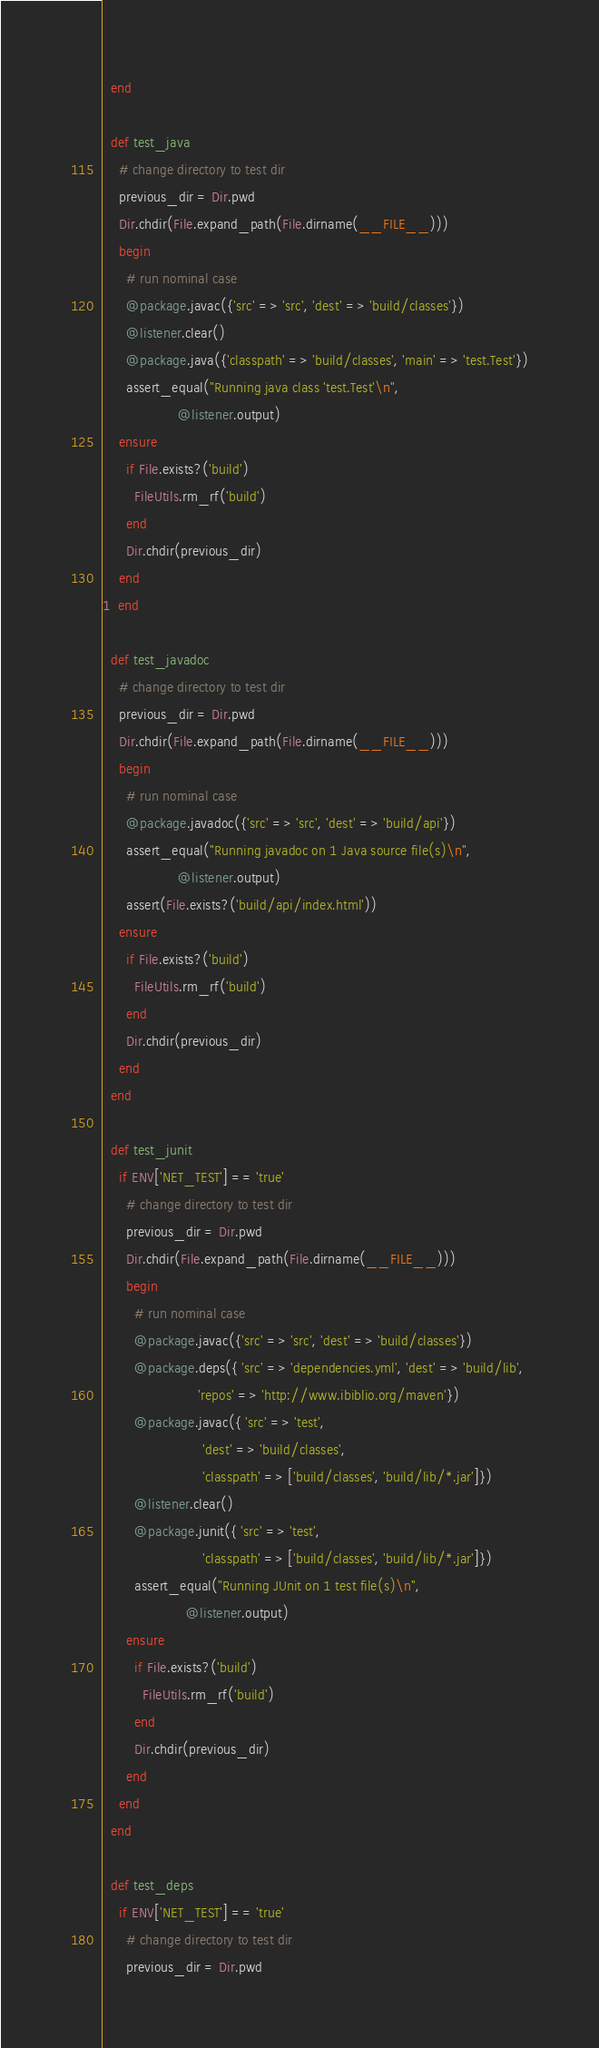Convert code to text. <code><loc_0><loc_0><loc_500><loc_500><_Ruby_>  end

  def test_java
    # change directory to test dir
    previous_dir = Dir.pwd
    Dir.chdir(File.expand_path(File.dirname(__FILE__)))
    begin
      # run nominal case
      @package.javac({'src' => 'src', 'dest' => 'build/classes'})
      @listener.clear()
      @package.java({'classpath' => 'build/classes', 'main' => 'test.Test'})
      assert_equal("Running java class 'test.Test'\n",
                   @listener.output)
    ensure
      if File.exists?('build')
        FileUtils.rm_rf('build')
      end
      Dir.chdir(previous_dir)
    end
1  end

  def test_javadoc
    # change directory to test dir
    previous_dir = Dir.pwd
    Dir.chdir(File.expand_path(File.dirname(__FILE__)))
    begin
      # run nominal case
      @package.javadoc({'src' => 'src', 'dest' => 'build/api'})
      assert_equal("Running javadoc on 1 Java source file(s)\n",
                   @listener.output)
      assert(File.exists?('build/api/index.html'))
    ensure
      if File.exists?('build')
        FileUtils.rm_rf('build')
      end
      Dir.chdir(previous_dir)
    end
  end

  def test_junit
    if ENV['NET_TEST'] == 'true'
      # change directory to test dir
      previous_dir = Dir.pwd
      Dir.chdir(File.expand_path(File.dirname(__FILE__)))
      begin
        # run nominal case
        @package.javac({'src' => 'src', 'dest' => 'build/classes'})
        @package.deps({ 'src' => 'dependencies.yml', 'dest' => 'build/lib',
                        'repos' => 'http://www.ibiblio.org/maven'})
        @package.javac({ 'src' => 'test',
                         'dest' => 'build/classes',
                         'classpath' => ['build/classes', 'build/lib/*.jar']})
        @listener.clear()
        @package.junit({ 'src' => 'test',
                         'classpath' => ['build/classes', 'build/lib/*.jar']})
        assert_equal("Running JUnit on 1 test file(s)\n",
                     @listener.output)
      ensure
        if File.exists?('build')
          FileUtils.rm_rf('build')
        end
        Dir.chdir(previous_dir)
      end
    end
  end

  def test_deps
    if ENV['NET_TEST'] == 'true'
      # change directory to test dir
      previous_dir = Dir.pwd</code> 